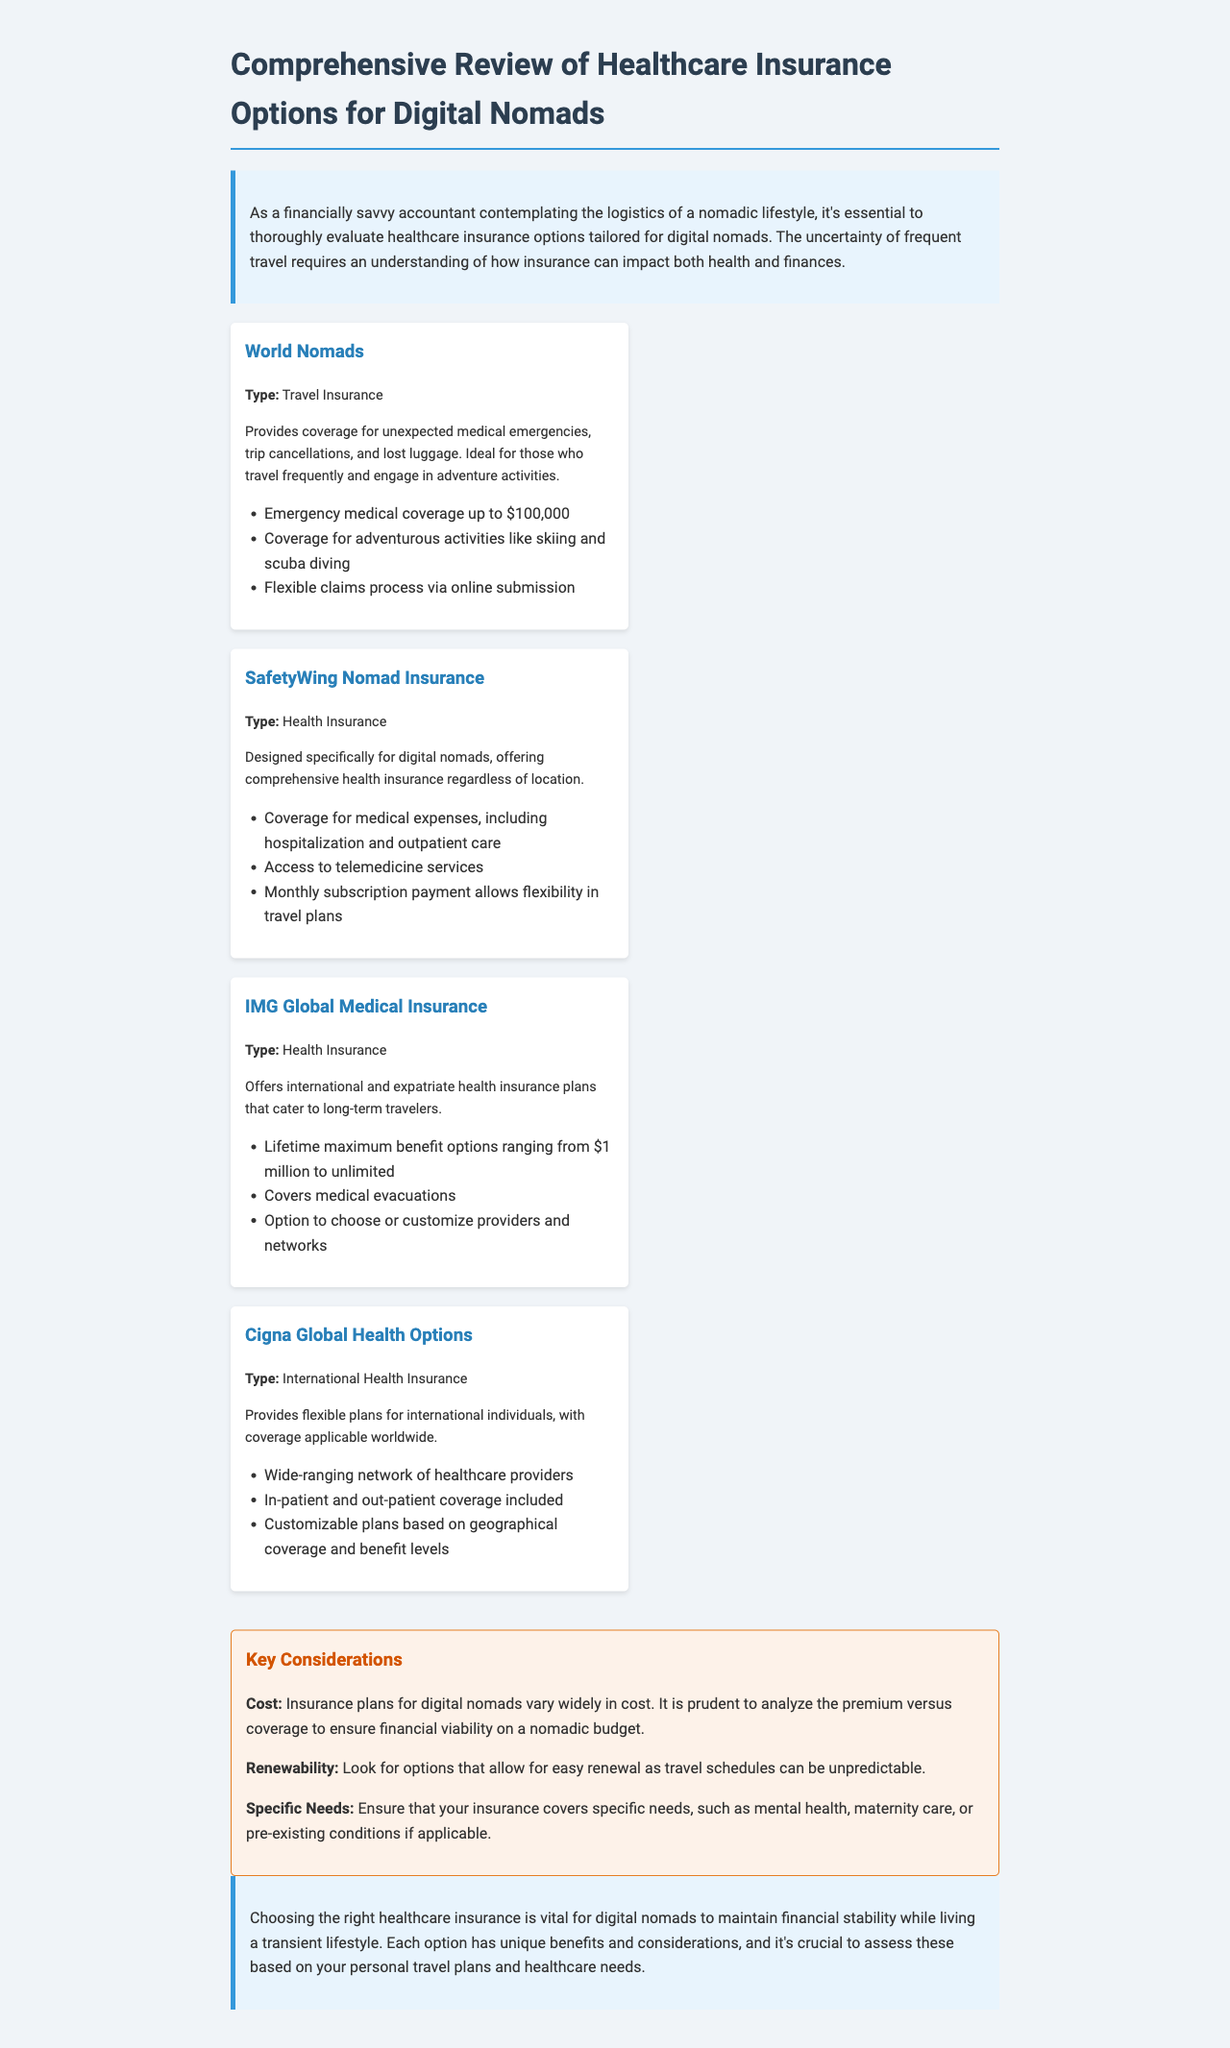What is the main focus of the document? The document provides a comprehensive review of healthcare insurance options specifically for digital nomads.
Answer: healthcare insurance options for digital nomads What type of insurance does World Nomads offer? World Nomads provides travel insurance, which covers unexpected medical emergencies, trip cancellations, and lost luggage.
Answer: Travel Insurance What is the maximum emergency medical coverage provided by World Nomads? The document states that World Nomads offers emergency medical coverage up to $100,000.
Answer: $100,000 Which insurance option is designed specifically for digital nomads? SafetyWing Nomad Insurance is tailored for digital nomads, offering comprehensive health insurance regardless of location.
Answer: SafetyWing Nomad Insurance What is a key consideration mentioned regarding insurance plans? The document emphasizes the importance of analyzing the premium versus coverage to ensure financial viability on a nomadic budget.
Answer: Cost Which insurance option includes telemedicine services? SafetyWing Nomad Insurance includes access to telemedicine services.
Answer: SafetyWing Nomad Insurance How can Cigna Global Health Options plans be customized? Cigna Global Health Options plans can be customized based on geographical coverage and benefit levels.
Answer: Customizable plans What is a common potential challenge for digital nomads regarding insurance? Digital nomads may face unpredictable travel schedules, making renewability of insurance plans crucial.
Answer: Renewability 